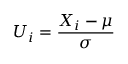Convert formula to latex. <formula><loc_0><loc_0><loc_500><loc_500>U _ { i } = { \frac { X _ { i } - \mu } { \sigma } }</formula> 